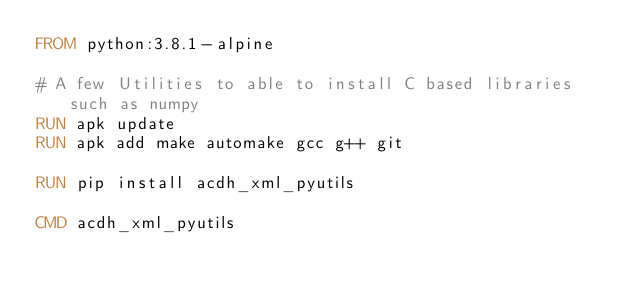<code> <loc_0><loc_0><loc_500><loc_500><_Dockerfile_>FROM python:3.8.1-alpine

# A few Utilities to able to install C based libraries such as numpy
RUN apk update
RUN apk add make automake gcc g++ git

RUN pip install acdh_xml_pyutils

CMD acdh_xml_pyutils
</code> 